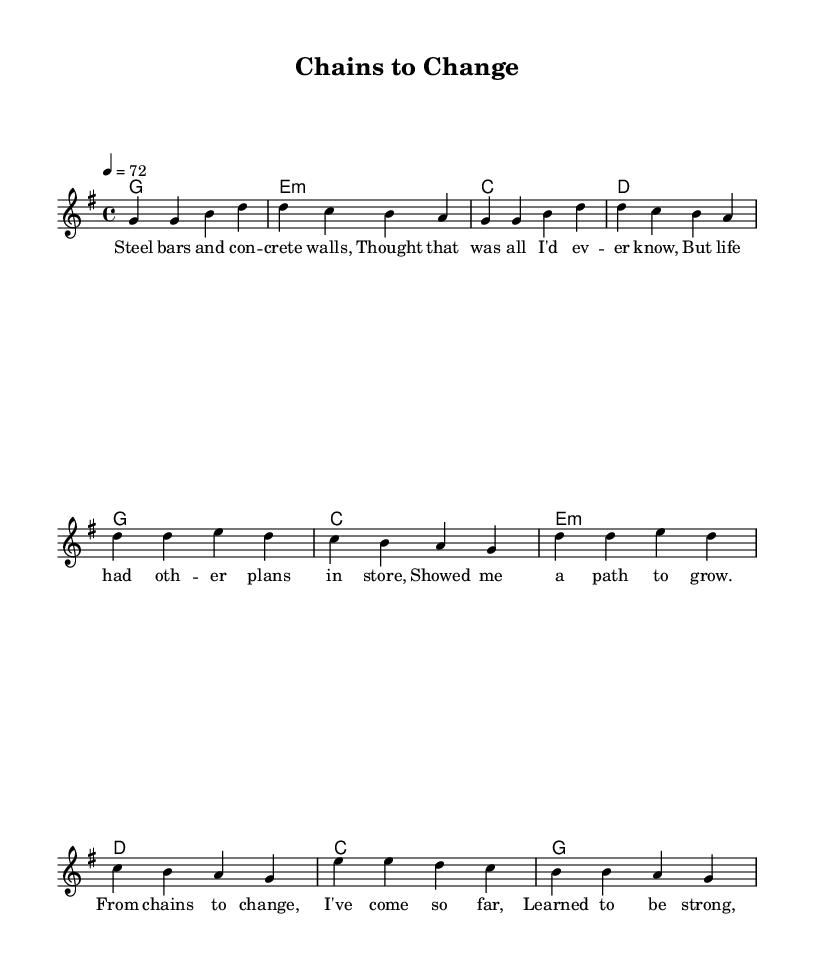What is the key signature of this music? The key signature is indicated by the placement of sharps or flats at the beginning of the staff. This music has one sharp, which corresponds to the key of G major.
Answer: G major What is the time signature of this music? The time signature is located at the beginning of the staff, indicating how many beats are in each measure. This music has a time signature of 4/4, meaning there are four beats per measure.
Answer: 4/4 What is the tempo of this music? The tempo marking is shown at the beginning and indicates the speed of the piece. It states that the tempo is 72 beats per minute, which is moderate.
Answer: 72 How many measures are in the verse? By counting the number of sets of vertical lines that separate the notes in the verse section, we find that it consists of four measures.
Answer: Four What is the main theme of the lyrics? The lyrics reflect personal growth and transformation, focusing on moving from a difficult past to a hopeful future. This can be inferred through phrases discussing chains, change, and scars.
Answer: Personal growth What type of chord progression is used in the chorus? The chord progression in the chorus can be identified by looking at the chord symbols and arranging them in a common format. It follows a G, C, E minor, D progression, which is typical in country music for its uplifting feel.
Answer: G, C, E minor, D What element of storytelling is present in the bridge? The bridge includes a reflective questioning element that emphasizes the idea that the past does not define the future. This is indicated through the lyrics that focus on choices and direction.
Answer: Reflection 